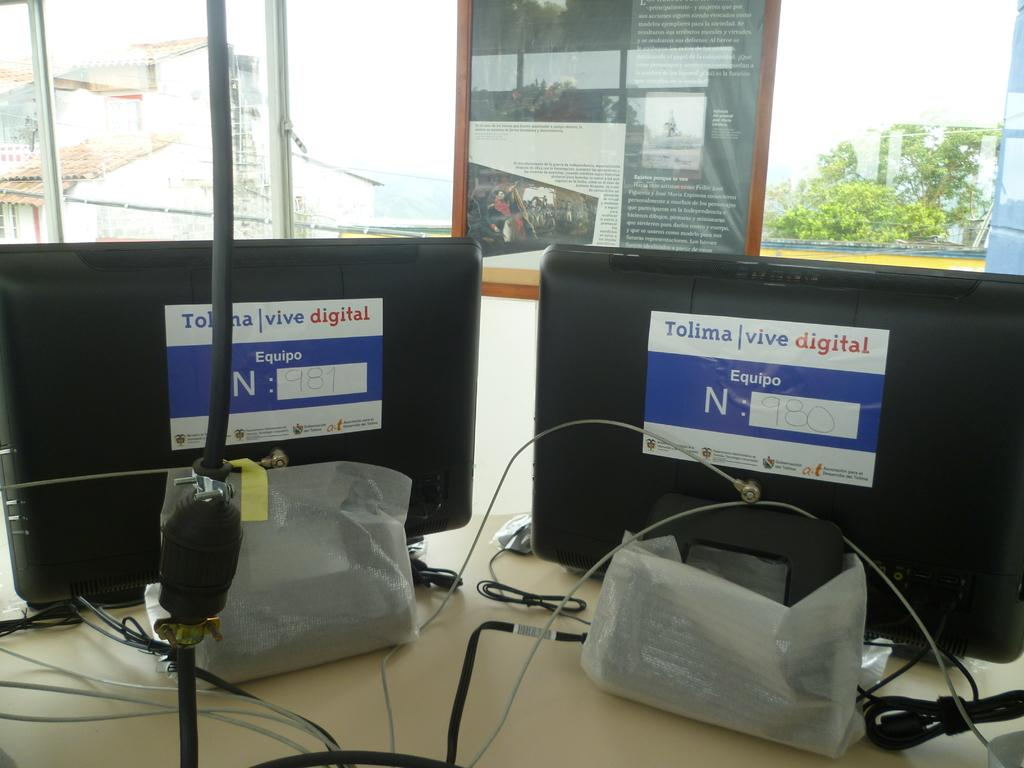<image>
Provide a brief description of the given image. A pair of monitors on a desk with signs on the back that say Tollima vive digital. 